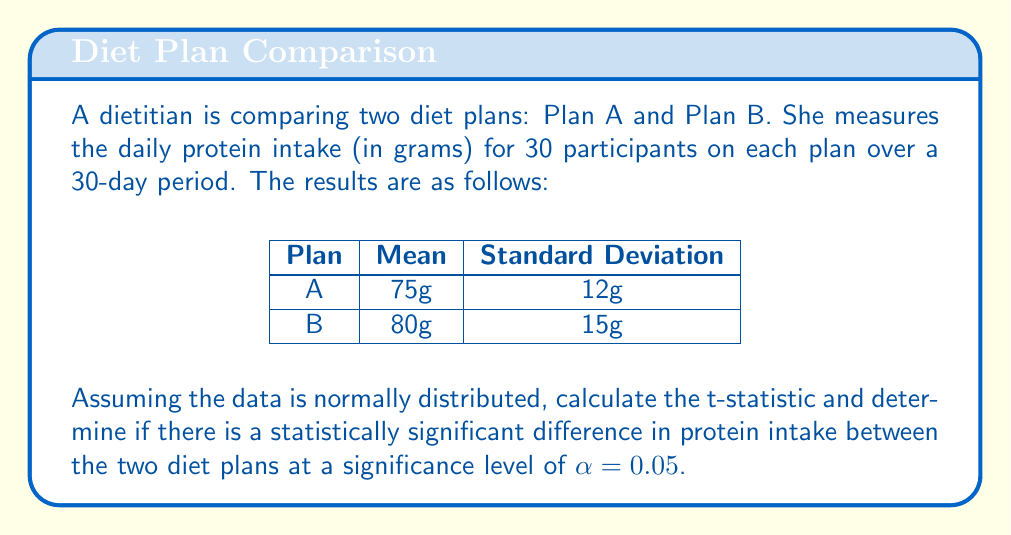Can you solve this math problem? To determine if there is a statistically significant difference between the two diet plans, we'll use an independent samples t-test. Here are the steps:

1. Calculate the pooled standard error:
   $$SE = \sqrt{\frac{s_1^2}{n_1} + \frac{s_2^2}{n_2}}$$
   Where $s_1$ and $s_2$ are the standard deviations, and $n_1$ and $n_2$ are the sample sizes.
   
   $$SE = \sqrt{\frac{12^2}{30} + \frac{15^2}{30}} = \sqrt{4.8 + 7.5} = \sqrt{12.3} \approx 3.51$$

2. Calculate the t-statistic:
   $$t = \frac{\bar{x_1} - \bar{x_2}}{SE}$$
   Where $\bar{x_1}$ and $\bar{x_2}$ are the sample means.
   
   $$t = \frac{75 - 80}{3.51} \approx -1.42$$

3. Determine the degrees of freedom:
   $$df = n_1 + n_2 - 2 = 30 + 30 - 2 = 58$$

4. Find the critical t-value for a two-tailed test at α = 0.05 with 58 degrees of freedom:
   $t_{critical} \approx \pm 2.002$

5. Compare the calculated t-statistic to the critical t-value:
   Since $|-1.42| < 2.002$, we fail to reject the null hypothesis.

Therefore, there is not enough evidence to conclude that there is a statistically significant difference in protein intake between the two diet plans at the 0.05 significance level.
Answer: $t \approx -1.42$; Not statistically significant 